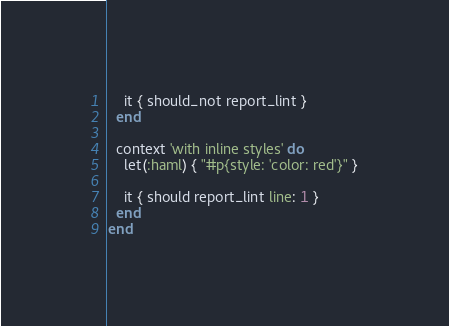Convert code to text. <code><loc_0><loc_0><loc_500><loc_500><_Ruby_>    it { should_not report_lint }
  end

  context 'with inline styles' do
    let(:haml) { "#p{style: 'color: red'}" }

    it { should report_lint line: 1 }
  end
end
</code> 